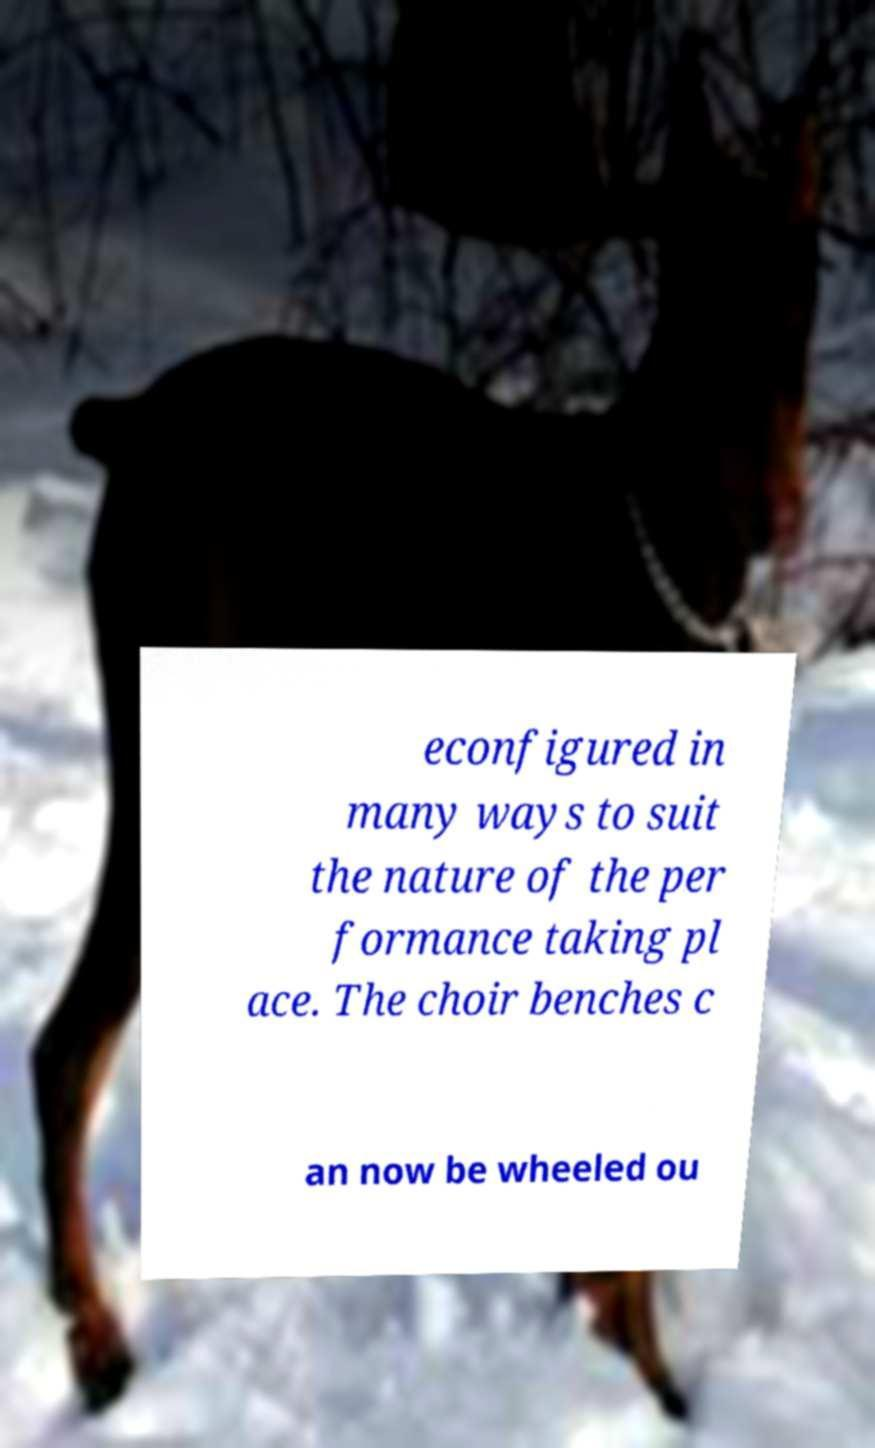I need the written content from this picture converted into text. Can you do that? econfigured in many ways to suit the nature of the per formance taking pl ace. The choir benches c an now be wheeled ou 